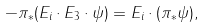<formula> <loc_0><loc_0><loc_500><loc_500>- \pi _ { \ast } ( E _ { i } \cdot E _ { 3 } \cdot \psi ) = E _ { i } \cdot ( \pi _ { \ast } \psi ) ,</formula> 